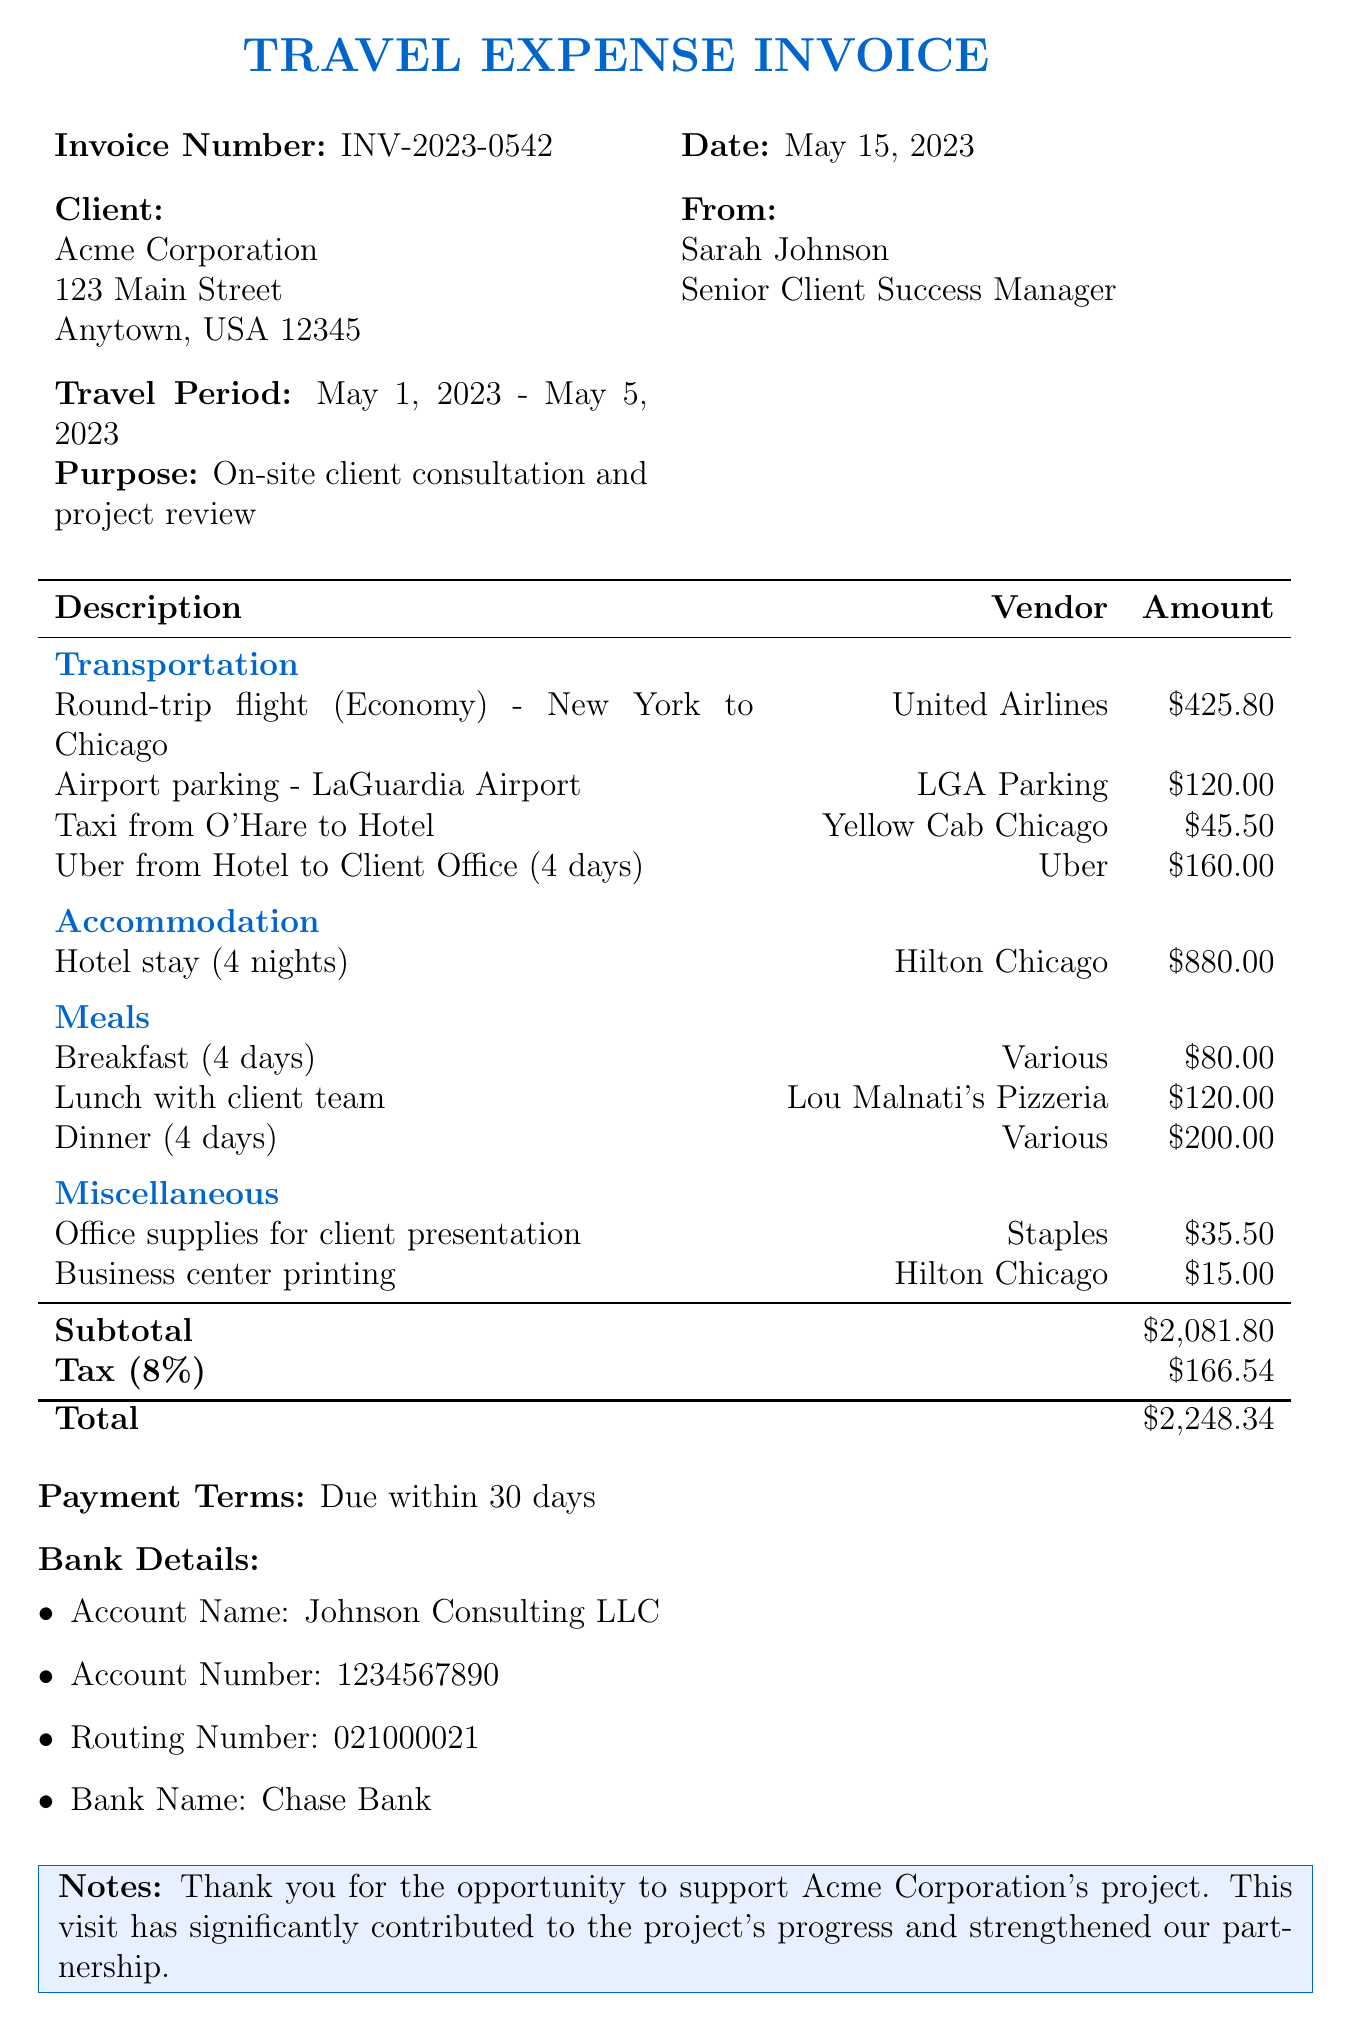What is the invoice number? The invoice number is a unique identifier for this document, stated in the header section.
Answer: INV-2023-0542 What is the date of the invoice? The date of the invoice is the issue date, which is also in the header section.
Answer: May 15, 2023 Who is the client? The client name is found prominently in the invoice header.
Answer: Acme Corporation What is the total amount due? The total amount is calculated by summing the subtotal and tax amount, listed in the totals section.
Answer: 2248.34 What are the payment terms? Payment terms are conditions under which payment is to be made, noted towards the end of the document.
Answer: Due within 30 days How many nights was the hotel stay? The duration of the hotel stay for accommodation expenses is mentioned under accommodations.
Answer: 4 nights What is the total expense for meals? The total meal expense is derived from the individual meal costs listed in the meals section of the document.
Answer: 400.00 What type of services does the manager provide? The manager's title reflects her role in the organization, giving insight into her services.
Answer: Senior Client Success Manager What is the purpose of the travel? The purpose of the travel is stated clearly in the respective section of the document.
Answer: On-site client consultation and project review 